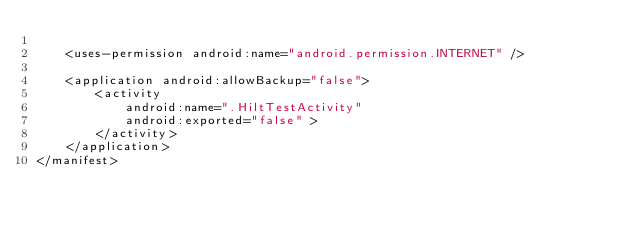<code> <loc_0><loc_0><loc_500><loc_500><_XML_>
    <uses-permission android:name="android.permission.INTERNET" />

    <application android:allowBackup="false">
        <activity
            android:name=".HiltTestActivity"
            android:exported="false" >
        </activity>
    </application>
</manifest></code> 